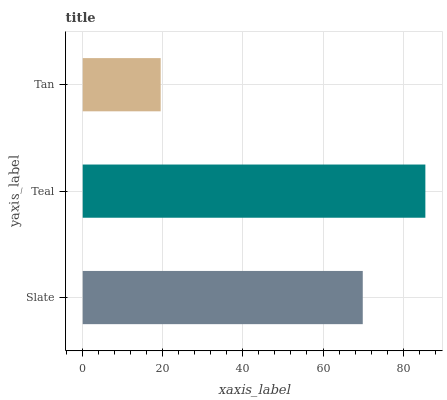Is Tan the minimum?
Answer yes or no. Yes. Is Teal the maximum?
Answer yes or no. Yes. Is Teal the minimum?
Answer yes or no. No. Is Tan the maximum?
Answer yes or no. No. Is Teal greater than Tan?
Answer yes or no. Yes. Is Tan less than Teal?
Answer yes or no. Yes. Is Tan greater than Teal?
Answer yes or no. No. Is Teal less than Tan?
Answer yes or no. No. Is Slate the high median?
Answer yes or no. Yes. Is Slate the low median?
Answer yes or no. Yes. Is Teal the high median?
Answer yes or no. No. Is Teal the low median?
Answer yes or no. No. 